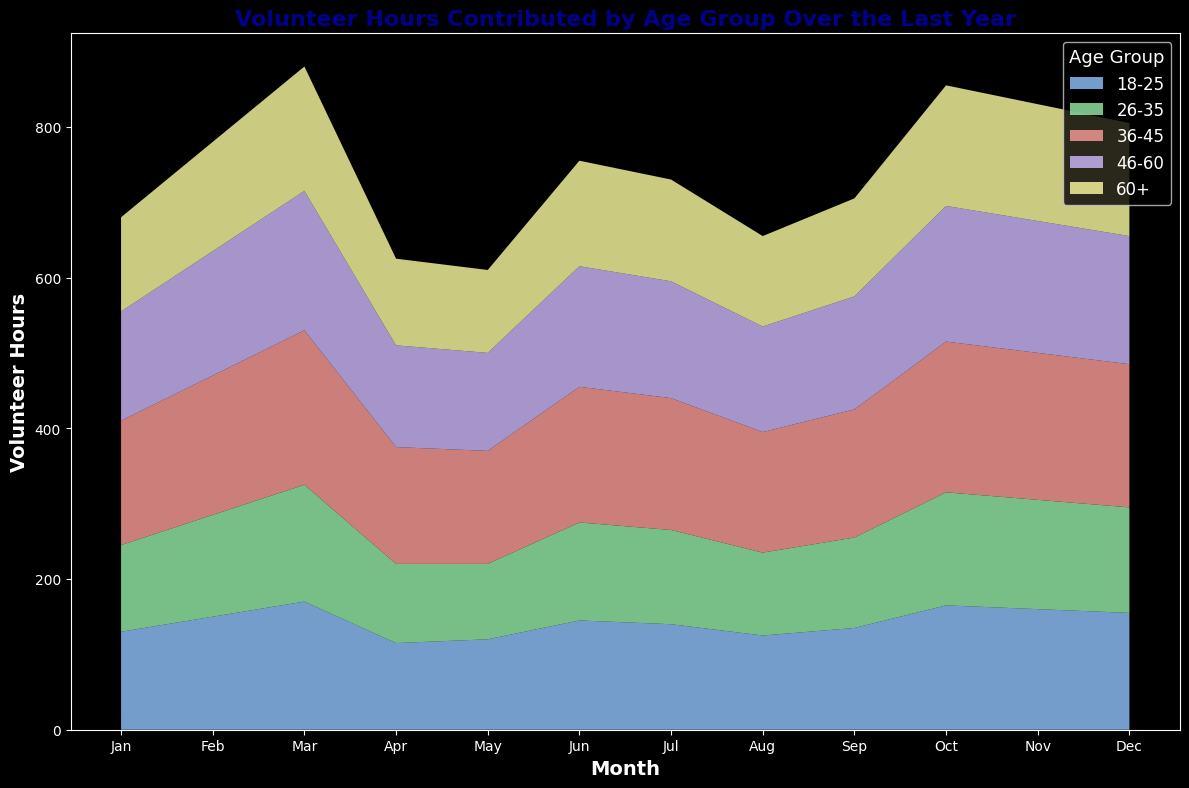What is the total number of volunteer hours contributed by the 36-45 age group in December? Find the height of the area representing the 36-45 age group for December and read its value.
Answer: 205 Which age group contributed the least volunteer hours in January? Look at the heights of the areas for each age group in January and identify the smallest one.
Answer: 26-35 Which age group shows a consistent increase in volunteer hours every month? Observe the trend for each age group and identify which one continually increases without a drop.
Answer: 18-25 What is the difference in volunteer hours contributed by the 18-25 age group between January and December? Subtract the January value from the December value for the 18-25 age group (170 - 120).
Answer: 50 Between the 46-60 and 60+ age groups, which had higher volunteer hours in June? Compare the heights of the areas for the 46-60 and 60+ age groups in June.
Answer: 46-60 Which age group contributed the most volunteer hours in August? Find the age group with the highest area in August.
Answer: 36-45 On average, how many volunteer hours per month did the 26-35 age group contribute over the year? Sum the monthly values for the 26-35 age group and divide by 12 (100+105+110+115+120+125+130+135+140+145+150+155)/12.
Answer: 127.5 What is the sum of volunteer hours contributed by all age groups in March? Add the values for all age groups in March (125+110+160+140+120).
Answer: 655 Which month saw the highest total volunteer hours contributed by all age groups? Sum the values for every month across all age groups and identify the highest one.
Answer: December By how much did the volunteer hours contributed by the 36-45 age group change from May to July? Subtract the value in May from the value in July for the 36-45 age group (180 - 170).
Answer: 10 